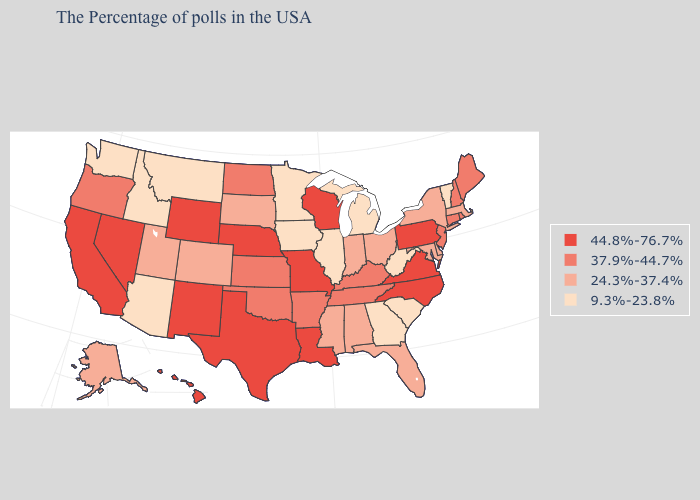What is the lowest value in states that border Washington?
Be succinct. 9.3%-23.8%. Which states have the lowest value in the South?
Quick response, please. South Carolina, West Virginia, Georgia. Among the states that border California , which have the highest value?
Quick response, please. Nevada. Name the states that have a value in the range 44.8%-76.7%?
Be succinct. Pennsylvania, Virginia, North Carolina, Wisconsin, Louisiana, Missouri, Nebraska, Texas, Wyoming, New Mexico, Nevada, California, Hawaii. Name the states that have a value in the range 37.9%-44.7%?
Write a very short answer. Maine, Rhode Island, New Hampshire, Connecticut, New Jersey, Kentucky, Tennessee, Arkansas, Kansas, Oklahoma, North Dakota, Oregon. Name the states that have a value in the range 44.8%-76.7%?
Keep it brief. Pennsylvania, Virginia, North Carolina, Wisconsin, Louisiana, Missouri, Nebraska, Texas, Wyoming, New Mexico, Nevada, California, Hawaii. Which states have the highest value in the USA?
Short answer required. Pennsylvania, Virginia, North Carolina, Wisconsin, Louisiana, Missouri, Nebraska, Texas, Wyoming, New Mexico, Nevada, California, Hawaii. Among the states that border Minnesota , which have the highest value?
Concise answer only. Wisconsin. Name the states that have a value in the range 37.9%-44.7%?
Quick response, please. Maine, Rhode Island, New Hampshire, Connecticut, New Jersey, Kentucky, Tennessee, Arkansas, Kansas, Oklahoma, North Dakota, Oregon. Name the states that have a value in the range 24.3%-37.4%?
Quick response, please. Massachusetts, New York, Delaware, Maryland, Ohio, Florida, Indiana, Alabama, Mississippi, South Dakota, Colorado, Utah, Alaska. What is the value of Oklahoma?
Short answer required. 37.9%-44.7%. How many symbols are there in the legend?
Write a very short answer. 4. Among the states that border Michigan , which have the highest value?
Be succinct. Wisconsin. Which states have the lowest value in the USA?
Concise answer only. Vermont, South Carolina, West Virginia, Georgia, Michigan, Illinois, Minnesota, Iowa, Montana, Arizona, Idaho, Washington. 